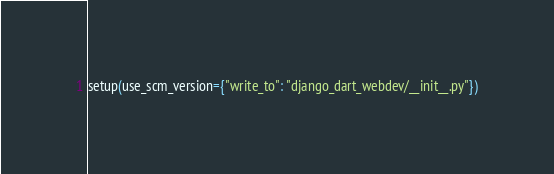<code> <loc_0><loc_0><loc_500><loc_500><_Python_>setup(use_scm_version={"write_to": "django_dart_webdev/__init__.py"})
</code> 